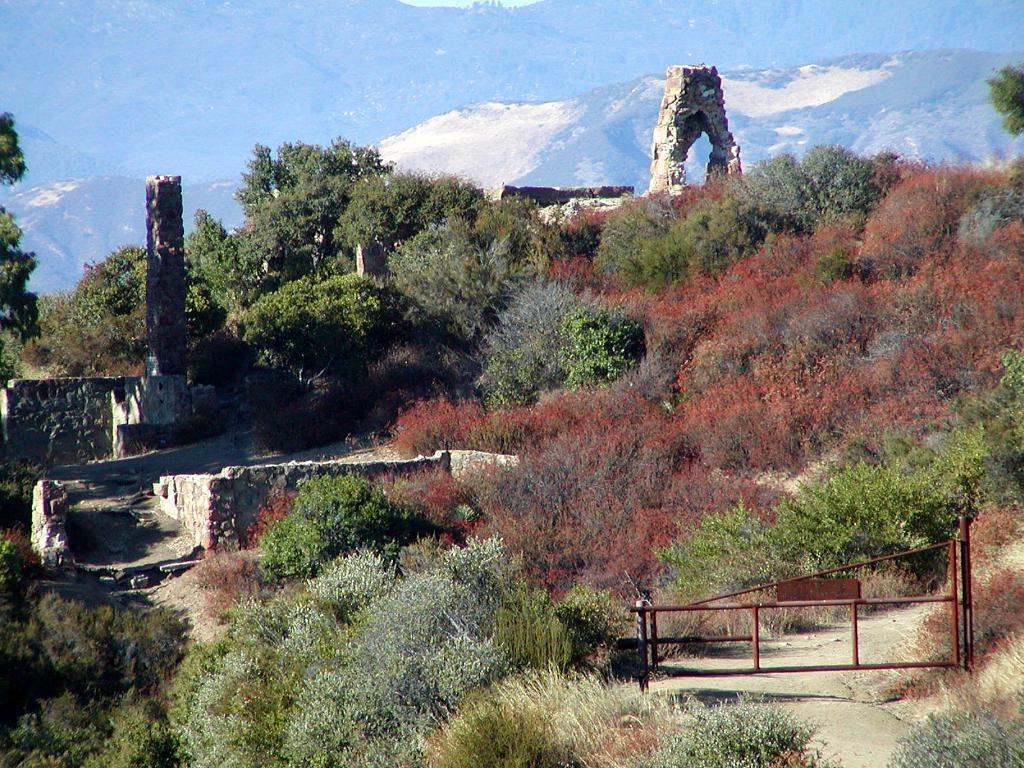What type of vegetation can be seen in the image? There are plants and trees in the image. What architectural features are present in the image? There are walls, a pillar, an arch, and a gate in the image. What natural feature is visible in the background of the image? There is a mountain in the background of the image. What caption is written on the gate in the image? There is no caption visible on the gate in the image. Can you describe the fire burning near the plants in the image? There is no fire present in the image; it only features plants, trees, walls, a pillar, an arch, a gate, and a mountain in the background. 